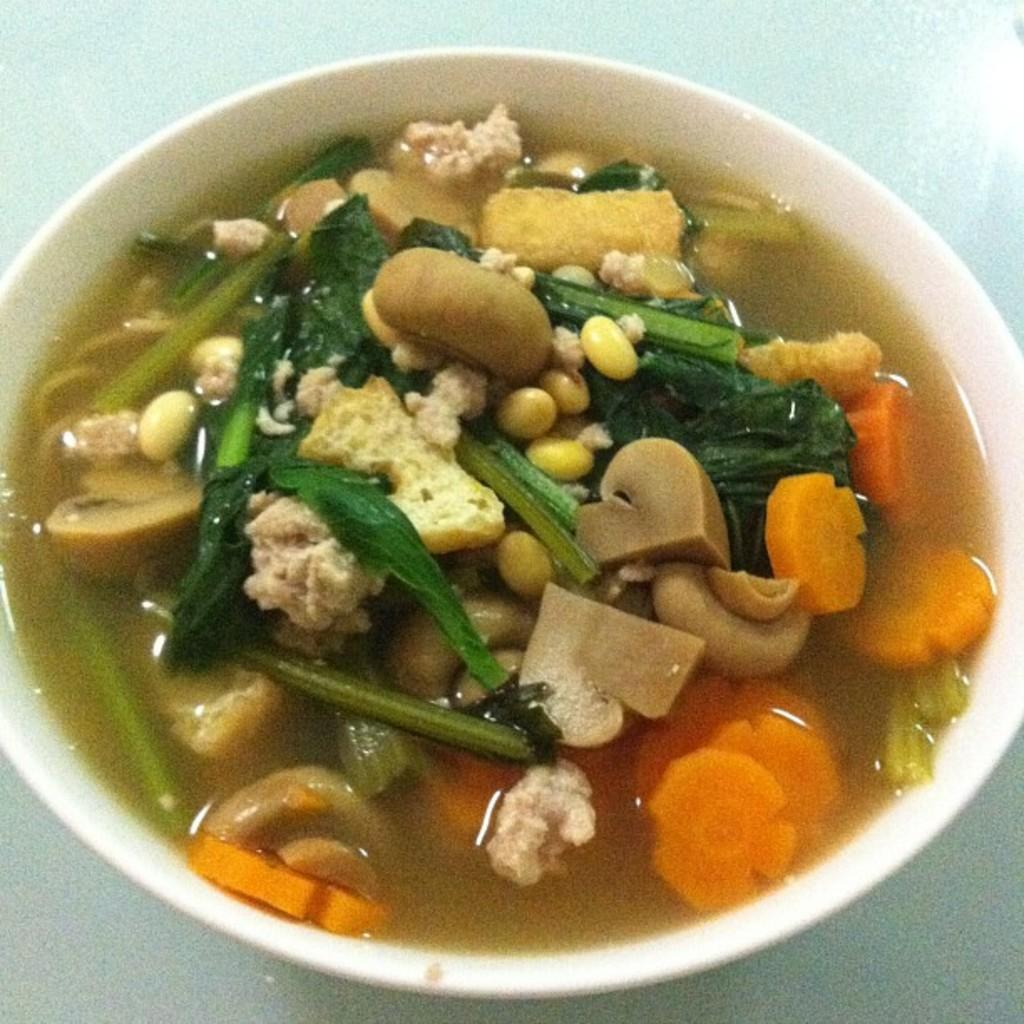Please provide a concise description of this image. In this picture I can see a white color bowl and in it I can see food, which is of green, cream, orange, yellow and brown color and it looks like a soup and this bowl is on the white color surface. 